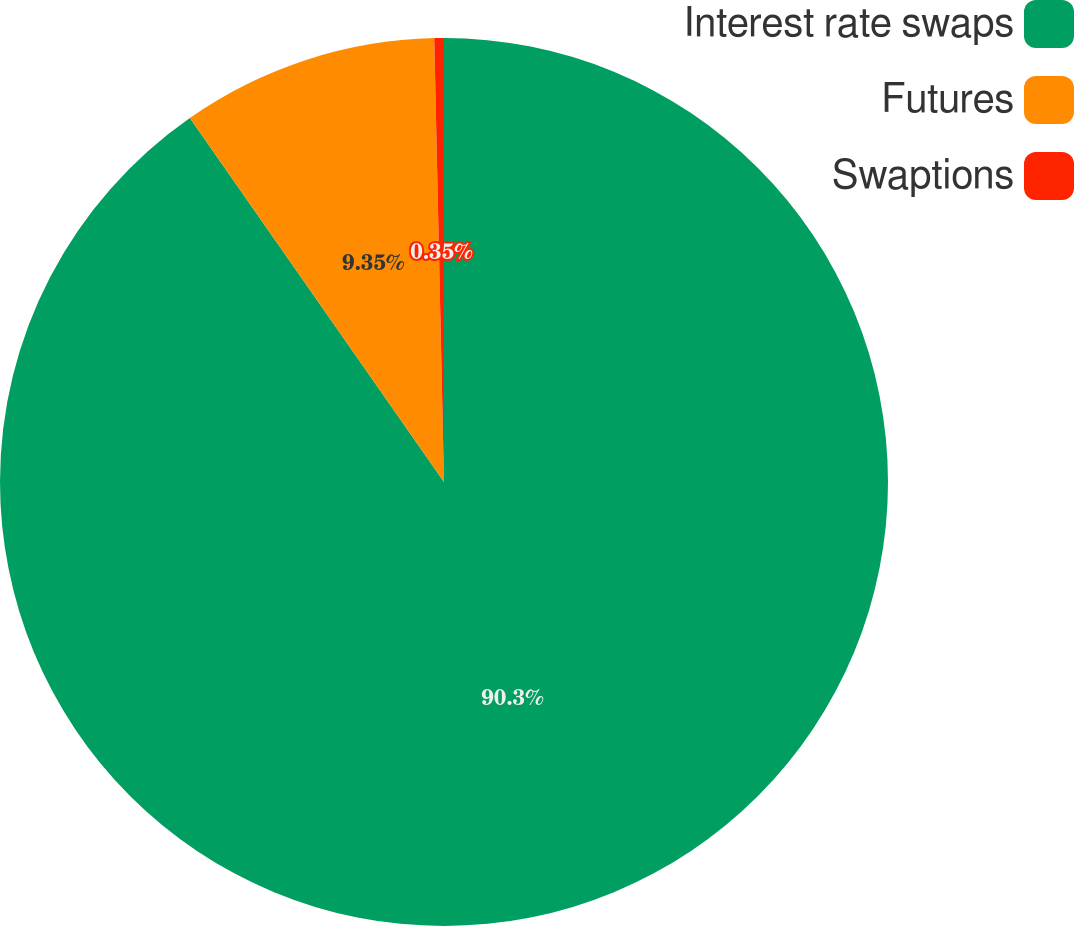Convert chart to OTSL. <chart><loc_0><loc_0><loc_500><loc_500><pie_chart><fcel>Interest rate swaps<fcel>Futures<fcel>Swaptions<nl><fcel>90.3%<fcel>9.35%<fcel>0.35%<nl></chart> 